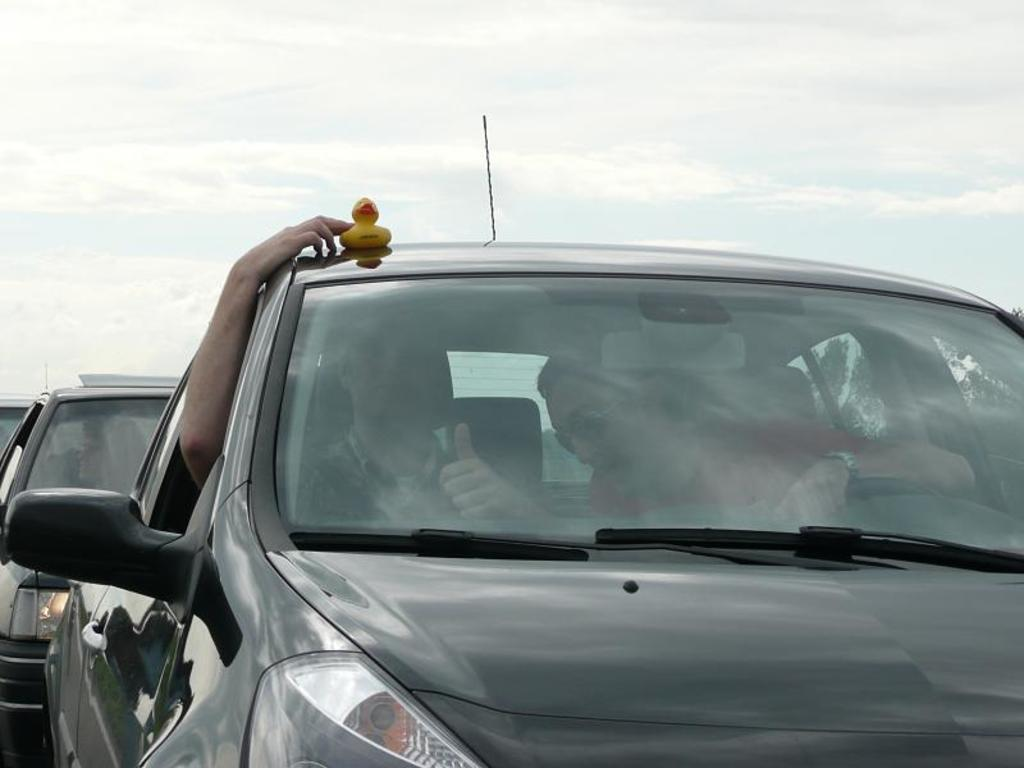What can be seen in the image? There are vehicles in the image, and two persons are sitting inside one of them. What is the person holding in the image? The person is holding a toy duck. What is visible in the background of the image? The sky is visible in the background of the image. What type of achiever is the person holding the toy duck? There is no indication in the image that the person holding the toy duck is an achiever, and therefore this detail cannot be determined from the image. 